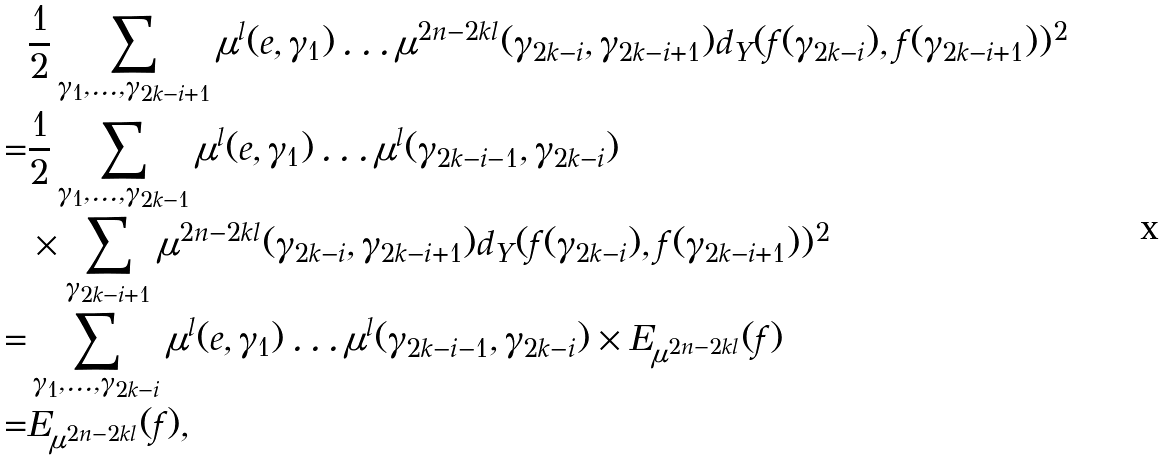Convert formula to latex. <formula><loc_0><loc_0><loc_500><loc_500>& \frac { 1 } { 2 } \sum _ { \gamma _ { 1 } , \dots , \gamma _ { 2 k - i + 1 } } \mu ^ { l } ( e , \gamma _ { 1 } ) \dots \mu ^ { 2 n - 2 k l } ( \gamma _ { 2 k - i } , \gamma _ { 2 k - i + 1 } ) d _ { Y } ( f ( \gamma _ { 2 k - i } ) , f ( \gamma _ { 2 k - i + 1 } ) ) ^ { 2 } \\ = & \frac { 1 } { 2 } \sum _ { \gamma _ { 1 } , \dots , \gamma _ { 2 k - 1 } } \mu ^ { l } ( e , \gamma _ { 1 } ) \dots \mu ^ { l } ( \gamma _ { 2 k - i - 1 } , \gamma _ { 2 k - i } ) \\ & \times \sum _ { \gamma _ { 2 k - i + 1 } } \mu ^ { 2 n - 2 k l } ( \gamma _ { 2 k - i } , \gamma _ { 2 k - i + 1 } ) d _ { Y } ( f ( \gamma _ { 2 k - i } ) , f ( \gamma _ { 2 k - i + 1 } ) ) ^ { 2 } \\ = & \sum _ { \gamma _ { 1 } , \dots , \gamma _ { 2 k - i } } \mu ^ { l } ( e , \gamma _ { 1 } ) \dots \mu ^ { l } ( \gamma _ { 2 k - i - 1 } , \gamma _ { 2 k - i } ) \times E _ { \mu ^ { 2 n - 2 k l } } ( f ) \\ = & E _ { \mu ^ { 2 n - 2 k l } } ( f ) ,</formula> 